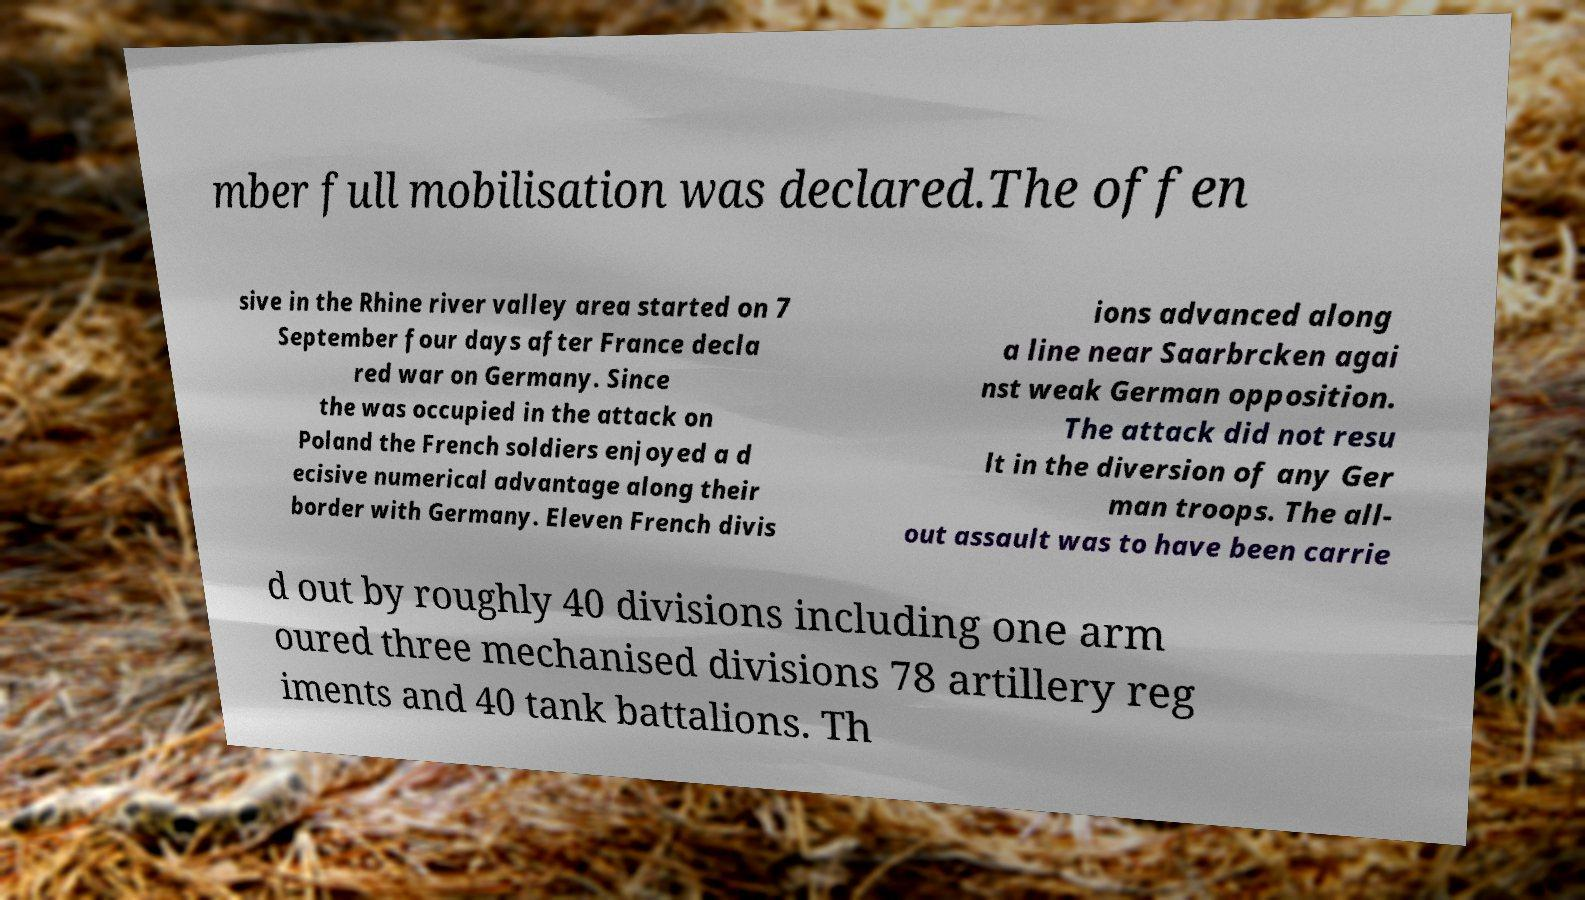Could you extract and type out the text from this image? mber full mobilisation was declared.The offen sive in the Rhine river valley area started on 7 September four days after France decla red war on Germany. Since the was occupied in the attack on Poland the French soldiers enjoyed a d ecisive numerical advantage along their border with Germany. Eleven French divis ions advanced along a line near Saarbrcken agai nst weak German opposition. The attack did not resu lt in the diversion of any Ger man troops. The all- out assault was to have been carrie d out by roughly 40 divisions including one arm oured three mechanised divisions 78 artillery reg iments and 40 tank battalions. Th 